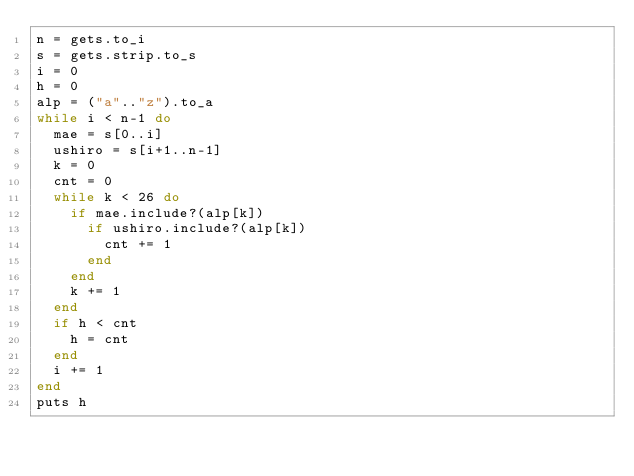<code> <loc_0><loc_0><loc_500><loc_500><_Ruby_>n = gets.to_i
s = gets.strip.to_s
i = 0
h = 0
alp = ("a".."z").to_a
while i < n-1 do
  mae = s[0..i]
  ushiro = s[i+1..n-1]
  k = 0
  cnt = 0
  while k < 26 do
    if mae.include?(alp[k])
      if ushiro.include?(alp[k])
        cnt += 1
      end
    end
    k += 1
  end
  if h < cnt
    h = cnt
  end
  i += 1
end
puts h</code> 